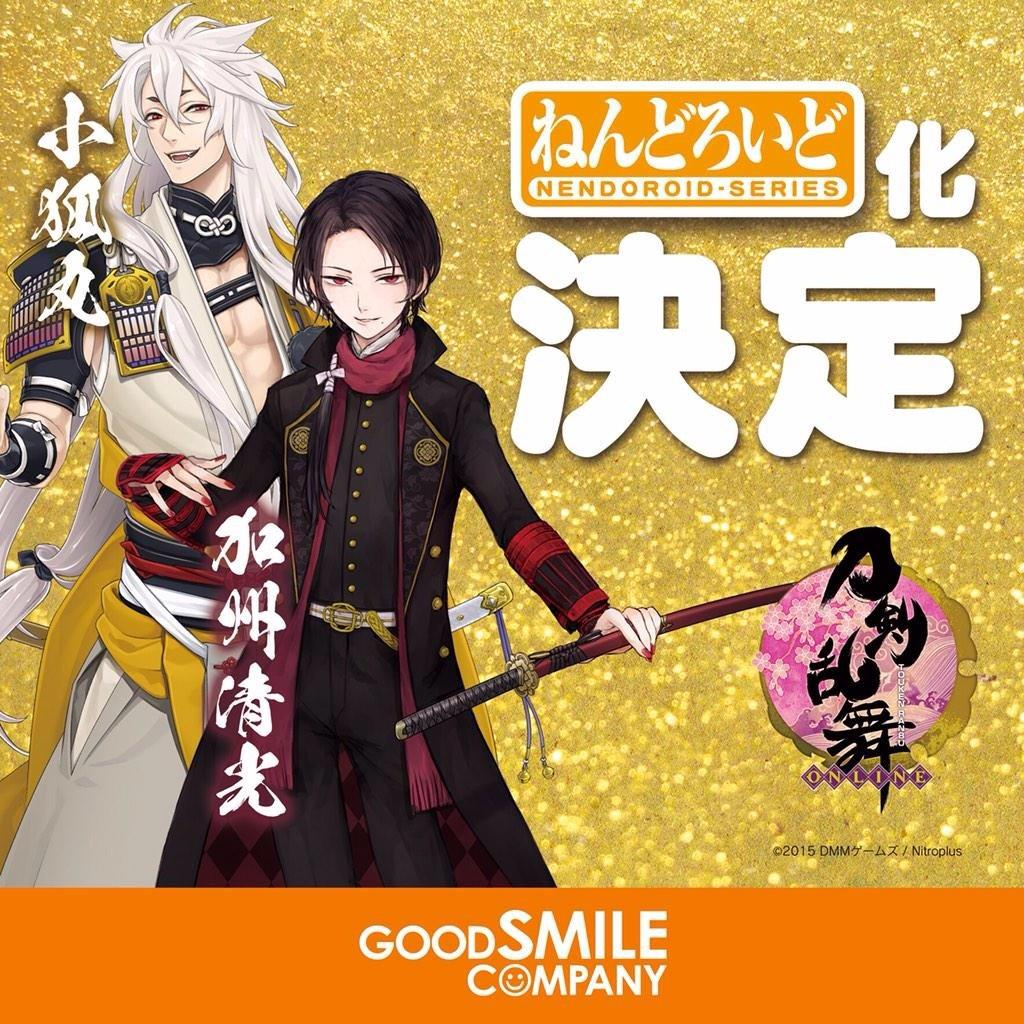How many cartoons are present in the image? There are two cartoons in the image. What colors are the cartoons wearing? One cartoon is wearing black, and the other is wearing white. What else can be seen in the image besides the cartoons? There is some text and a symbol in the image. Where is the pail located in the image? There is no pail present in the image. What type of bead is being used as a decoration in the image? There is no bead present in the image. 